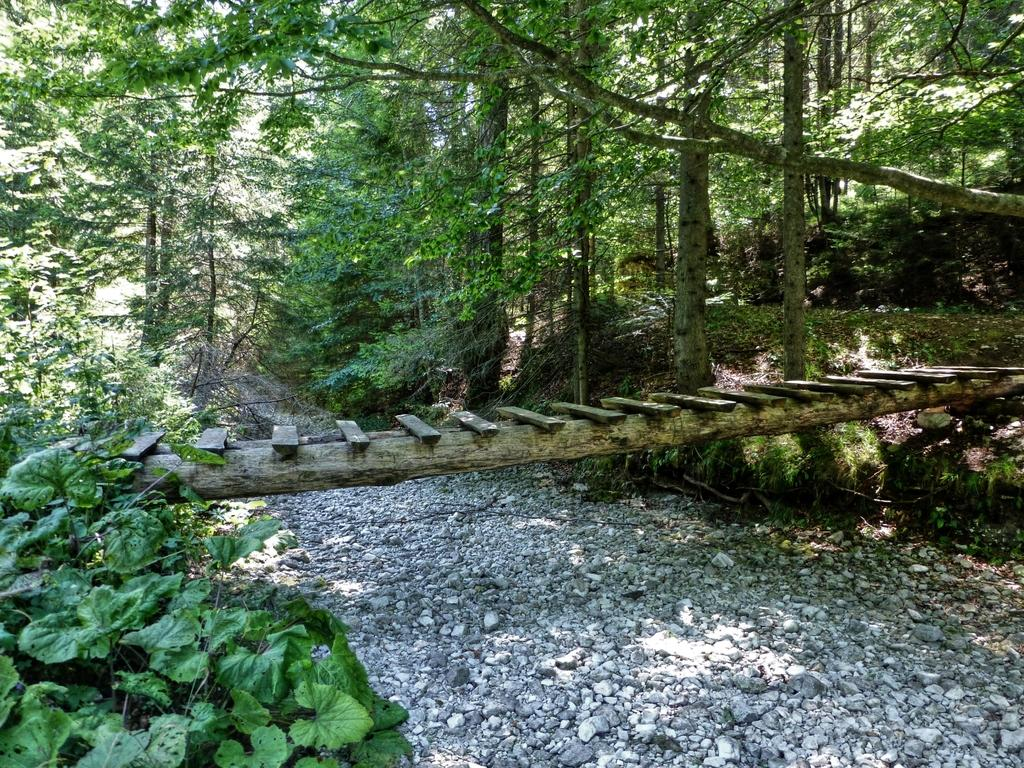What type of structure is present in the image? There is a wooden bridge in the image. What can be seen at the bottom of the image? Stones are visible at the bottom of the image. What type of natural scenery is visible in the background of the image? There are trees in the background of the image. What type of button can be seen on the wooden bridge in the image? There is no button present on the wooden bridge in the image. 